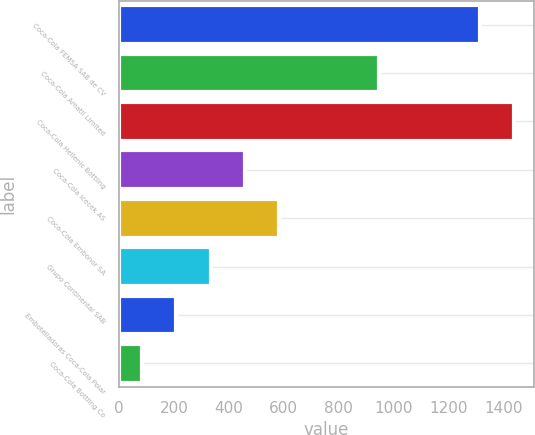Convert chart. <chart><loc_0><loc_0><loc_500><loc_500><bar_chart><fcel>Coca-Cola FEMSA SAB de CV<fcel>Coca-Cola Amatil Limited<fcel>Coca-Cola Hellenic Bottling<fcel>Coca-Cola Icecek AS<fcel>Coca-Cola Embonor SA<fcel>Grupo Continental SAB<fcel>Embotelladoras Coca-Cola Polar<fcel>Coca-Cola Bottling Co<nl><fcel>1315<fcel>948<fcel>1440.3<fcel>458.9<fcel>584.2<fcel>333.6<fcel>208.3<fcel>83<nl></chart> 